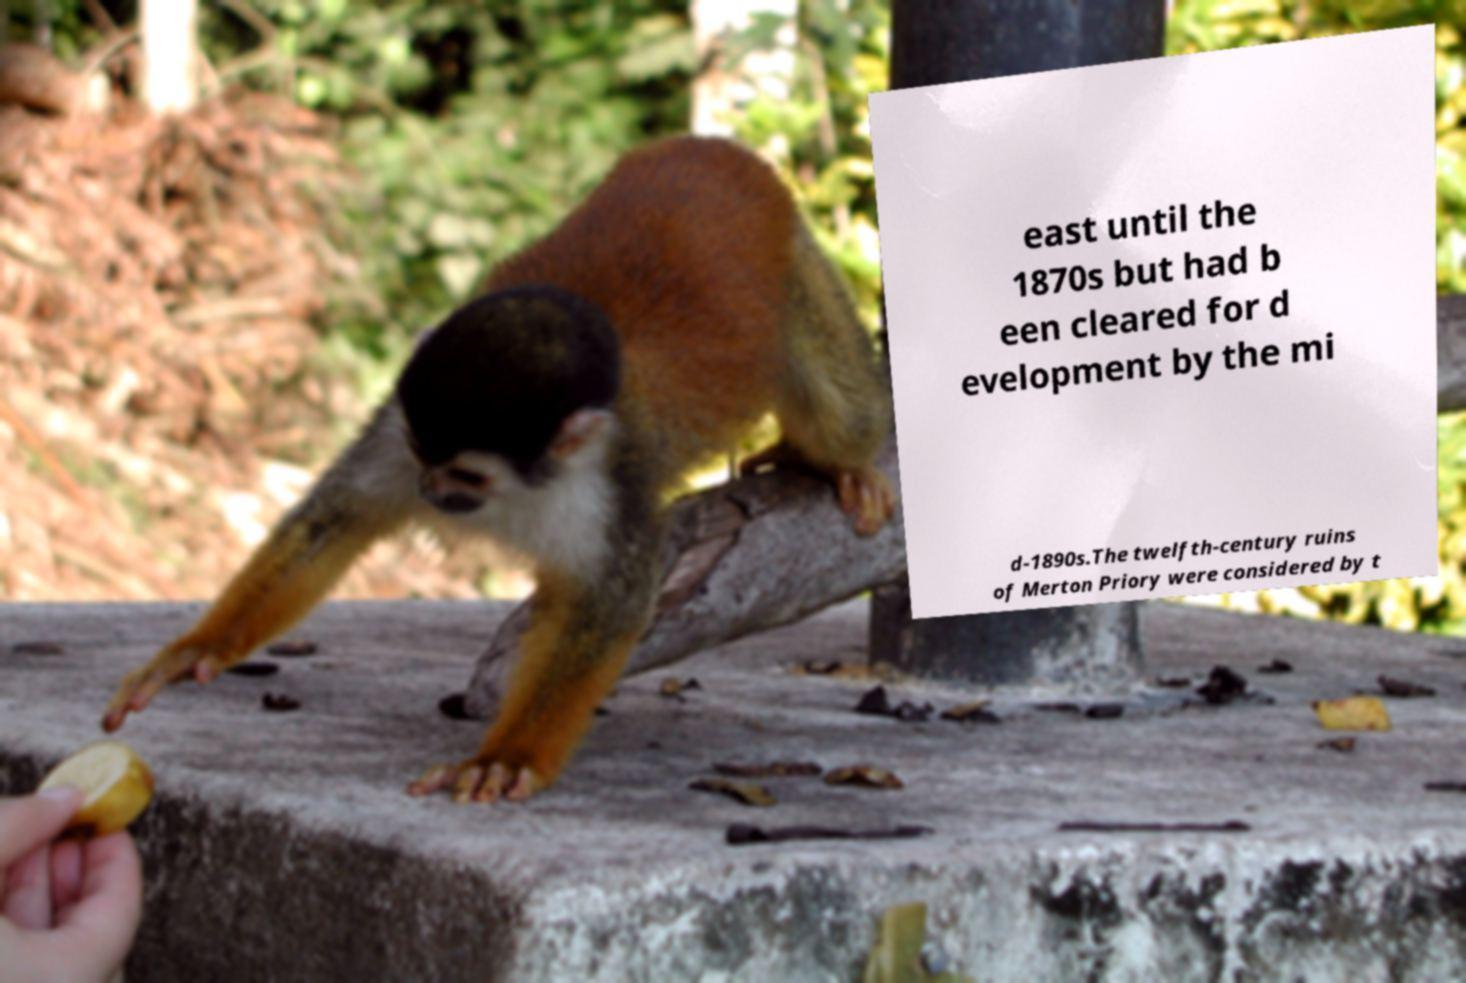Please identify and transcribe the text found in this image. east until the 1870s but had b een cleared for d evelopment by the mi d-1890s.The twelfth-century ruins of Merton Priory were considered by t 